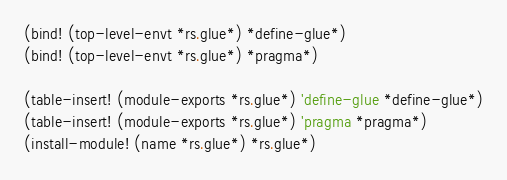Convert code to text. <code><loc_0><loc_0><loc_500><loc_500><_Scheme_>(bind! (top-level-envt *rs.glue*) *define-glue*)
(bind! (top-level-envt *rs.glue*) *pragma*)

(table-insert! (module-exports *rs.glue*) 'define-glue *define-glue*)
(table-insert! (module-exports *rs.glue*) 'pragma *pragma*)
(install-module! (name *rs.glue*) *rs.glue*)
</code> 